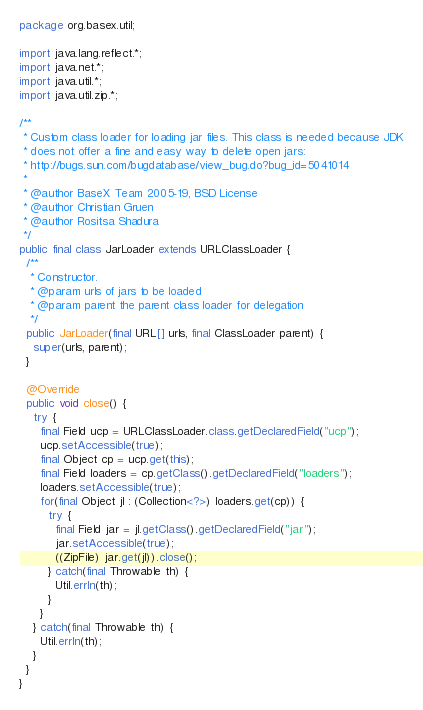Convert code to text. <code><loc_0><loc_0><loc_500><loc_500><_Java_>package org.basex.util;

import java.lang.reflect.*;
import java.net.*;
import java.util.*;
import java.util.zip.*;

/**
 * Custom class loader for loading jar files. This class is needed because JDK
 * does not offer a fine and easy way to delete open jars:
 * http://bugs.sun.com/bugdatabase/view_bug.do?bug_id=5041014
 *
 * @author BaseX Team 2005-19, BSD License
 * @author Christian Gruen
 * @author Rositsa Shadura
 */
public final class JarLoader extends URLClassLoader {
  /**
   * Constructor.
   * @param urls of jars to be loaded
   * @param parent the parent class loader for delegation
   */
  public JarLoader(final URL[] urls, final ClassLoader parent) {
    super(urls, parent);
  }

  @Override
  public void close() {
    try {
      final Field ucp = URLClassLoader.class.getDeclaredField("ucp");
      ucp.setAccessible(true);
      final Object cp = ucp.get(this);
      final Field loaders = cp.getClass().getDeclaredField("loaders");
      loaders.setAccessible(true);
      for(final Object jl : (Collection<?>) loaders.get(cp)) {
        try {
          final Field jar = jl.getClass().getDeclaredField("jar");
          jar.setAccessible(true);
          ((ZipFile) jar.get(jl)).close();
        } catch(final Throwable th) {
          Util.errln(th);
        }
      }
    } catch(final Throwable th) {
      Util.errln(th);
    }
  }
}
</code> 